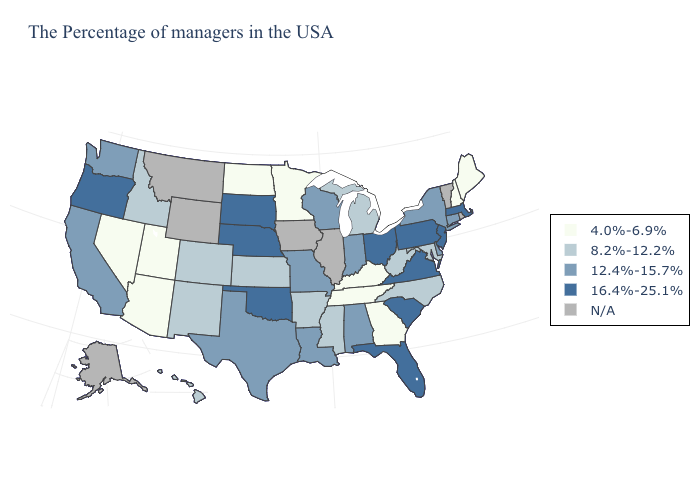Name the states that have a value in the range 12.4%-15.7%?
Concise answer only. Connecticut, New York, Delaware, Indiana, Alabama, Wisconsin, Louisiana, Missouri, Texas, California, Washington. Is the legend a continuous bar?
Write a very short answer. No. Does Michigan have the highest value in the MidWest?
Answer briefly. No. Does Tennessee have the highest value in the South?
Short answer required. No. How many symbols are there in the legend?
Give a very brief answer. 5. What is the value of Alaska?
Quick response, please. N/A. Does the first symbol in the legend represent the smallest category?
Be succinct. Yes. What is the highest value in the USA?
Be succinct. 16.4%-25.1%. Name the states that have a value in the range 8.2%-12.2%?
Concise answer only. Maryland, North Carolina, West Virginia, Michigan, Mississippi, Arkansas, Kansas, Colorado, New Mexico, Idaho, Hawaii. Name the states that have a value in the range 8.2%-12.2%?
Write a very short answer. Maryland, North Carolina, West Virginia, Michigan, Mississippi, Arkansas, Kansas, Colorado, New Mexico, Idaho, Hawaii. Does the first symbol in the legend represent the smallest category?
Quick response, please. Yes. Name the states that have a value in the range N/A?
Give a very brief answer. Rhode Island, Vermont, Illinois, Iowa, Wyoming, Montana, Alaska. What is the value of Oregon?
Write a very short answer. 16.4%-25.1%. Which states have the highest value in the USA?
Short answer required. Massachusetts, New Jersey, Pennsylvania, Virginia, South Carolina, Ohio, Florida, Nebraska, Oklahoma, South Dakota, Oregon. What is the value of Oklahoma?
Keep it brief. 16.4%-25.1%. 